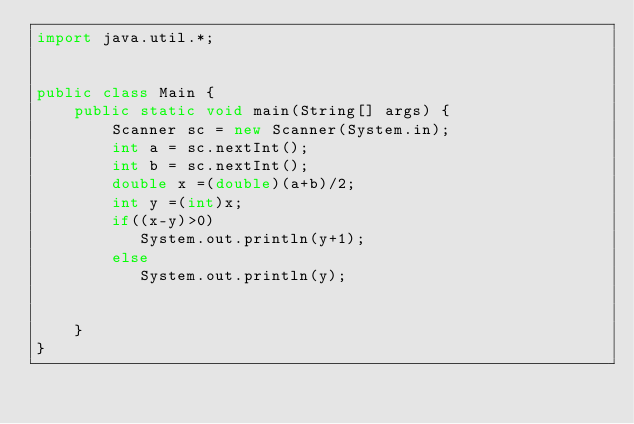<code> <loc_0><loc_0><loc_500><loc_500><_Java_>import java.util.*;
 

public class Main {
    public static void main(String[] args) {   
        Scanner sc = new Scanner(System.in);
        int a = sc.nextInt();
        int b = sc.nextInt();
        double x =(double)(a+b)/2;
        int y =(int)x;
        if((x-y)>0)
           System.out.println(y+1);
        else
           System.out.println(y);

		
    }
}

</code> 